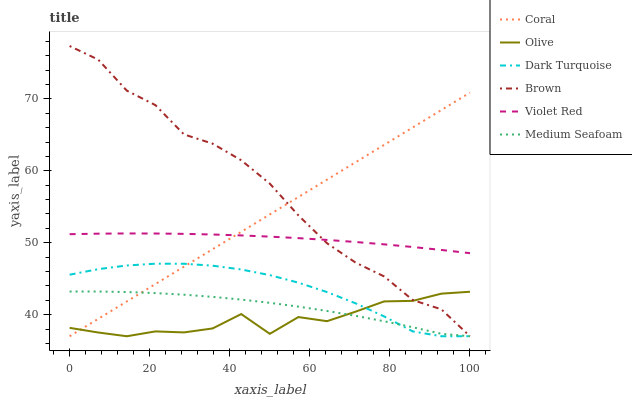Does Olive have the minimum area under the curve?
Answer yes or no. Yes. Does Brown have the maximum area under the curve?
Answer yes or no. Yes. Does Violet Red have the minimum area under the curve?
Answer yes or no. No. Does Violet Red have the maximum area under the curve?
Answer yes or no. No. Is Coral the smoothest?
Answer yes or no. Yes. Is Olive the roughest?
Answer yes or no. Yes. Is Violet Red the smoothest?
Answer yes or no. No. Is Violet Red the roughest?
Answer yes or no. No. Does Brown have the lowest value?
Answer yes or no. Yes. Does Violet Red have the lowest value?
Answer yes or no. No. Does Brown have the highest value?
Answer yes or no. Yes. Does Violet Red have the highest value?
Answer yes or no. No. Is Dark Turquoise less than Violet Red?
Answer yes or no. Yes. Is Violet Red greater than Dark Turquoise?
Answer yes or no. Yes. Does Brown intersect Dark Turquoise?
Answer yes or no. Yes. Is Brown less than Dark Turquoise?
Answer yes or no. No. Is Brown greater than Dark Turquoise?
Answer yes or no. No. Does Dark Turquoise intersect Violet Red?
Answer yes or no. No. 